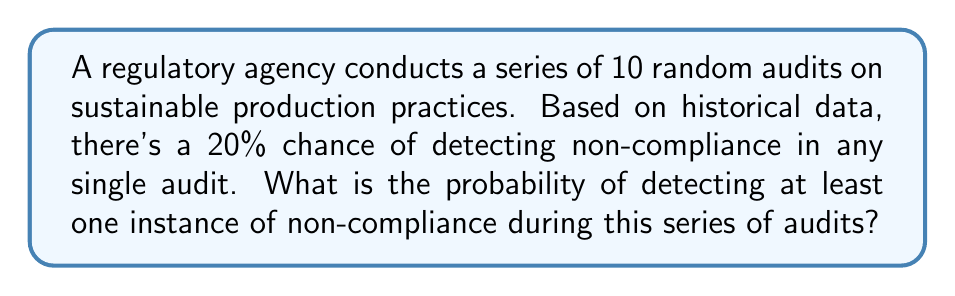Solve this math problem. Let's approach this step-by-step:

1) First, we need to recognize that this is a binomial probability problem. We're looking for the probability of at least one success (detecting non-compliance) in a series of independent trials (audits).

2) It's often easier to calculate the probability of at least one success by subtracting the probability of no successes from 1.

3) Let $p$ be the probability of detecting non-compliance in a single audit. We're given that $p = 0.20$ or 20%.

4) The probability of not detecting non-compliance in a single audit is therefore $1 - p = 1 - 0.20 = 0.80$ or 80%.

5) For no non-compliance to be detected in 10 audits, all 10 audits must fail to detect non-compliance. The probability of this is:

   $$(0.80)^{10} = 0.1074$$

6) Therefore, the probability of detecting at least one instance of non-compliance is:

   $$1 - (0.80)^{10} = 1 - 0.1074 = 0.8926$$

7) We can also express this using the binomial probability formula:

   $$P(X \geq 1) = 1 - P(X = 0) = 1 - \binom{10}{0}(0.20)^0(0.80)^{10} = 0.8926$$

   Where $X$ is the number of audits that detect non-compliance.
Answer: The probability of detecting at least one instance of non-compliance during the series of 10 audits is approximately 0.8926 or 89.26%. 